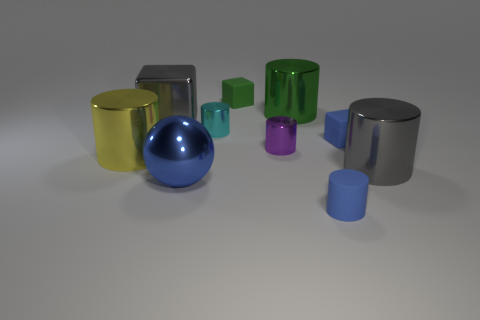There is a tiny cube that is the same color as the tiny matte cylinder; what material is it?
Your answer should be compact. Rubber. Do the gray metal thing in front of the small purple cylinder and the matte object that is to the left of the green metallic object have the same size?
Your response must be concise. No. There is a large gray metallic thing that is behind the tiny cyan cylinder; what shape is it?
Provide a succinct answer. Cube. What is the material of the blue object that is the same shape as the large green shiny thing?
Give a very brief answer. Rubber. Is the size of the blue metal object in front of the purple thing the same as the big yellow object?
Offer a very short reply. Yes. There is a yellow metallic thing; how many big gray cylinders are behind it?
Your answer should be compact. 0. Is the number of small cyan cylinders behind the yellow metal cylinder less than the number of rubber things to the right of the large green metallic cylinder?
Offer a very short reply. Yes. How many yellow metallic cylinders are there?
Provide a succinct answer. 1. The small matte thing behind the large metal block is what color?
Make the answer very short. Green. The purple shiny cylinder is what size?
Make the answer very short. Small. 